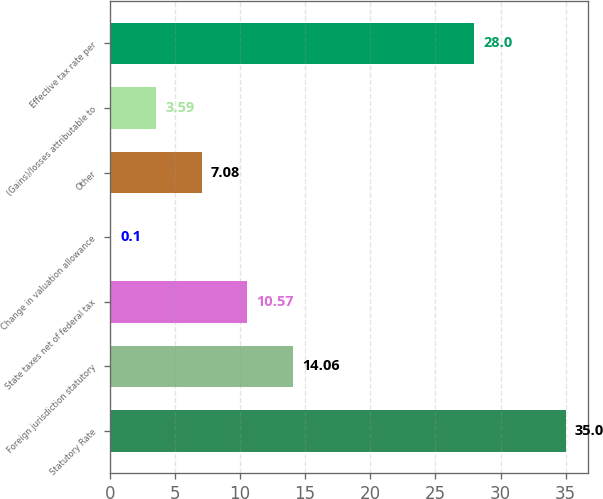Convert chart. <chart><loc_0><loc_0><loc_500><loc_500><bar_chart><fcel>Statutory Rate<fcel>Foreign jurisdiction statutory<fcel>State taxes net of federal tax<fcel>Change in valuation allowance<fcel>Other<fcel>(Gains)/losses attributable to<fcel>Effective tax rate per<nl><fcel>35<fcel>14.06<fcel>10.57<fcel>0.1<fcel>7.08<fcel>3.59<fcel>28<nl></chart> 